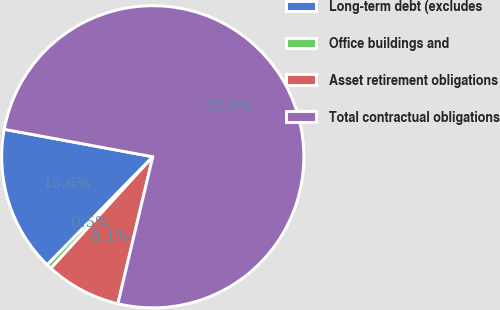<chart> <loc_0><loc_0><loc_500><loc_500><pie_chart><fcel>Long-term debt (excludes<fcel>Office buildings and<fcel>Asset retirement obligations<fcel>Total contractual obligations<nl><fcel>15.59%<fcel>0.54%<fcel>8.07%<fcel>75.8%<nl></chart> 